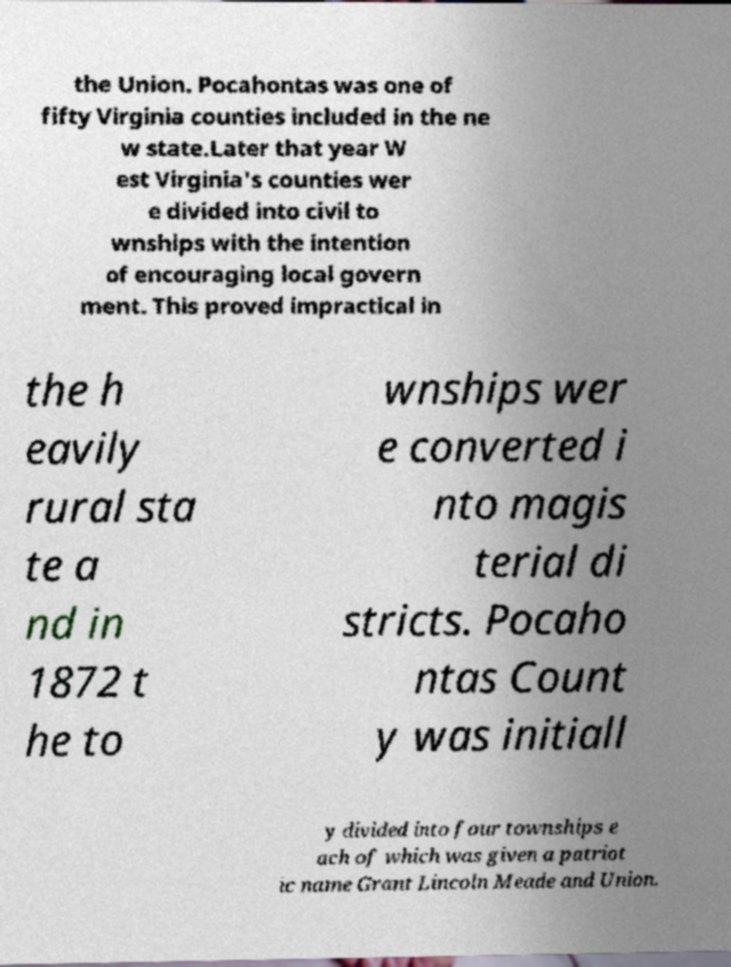For documentation purposes, I need the text within this image transcribed. Could you provide that? the Union. Pocahontas was one of fifty Virginia counties included in the ne w state.Later that year W est Virginia's counties wer e divided into civil to wnships with the intention of encouraging local govern ment. This proved impractical in the h eavily rural sta te a nd in 1872 t he to wnships wer e converted i nto magis terial di stricts. Pocaho ntas Count y was initiall y divided into four townships e ach of which was given a patriot ic name Grant Lincoln Meade and Union. 